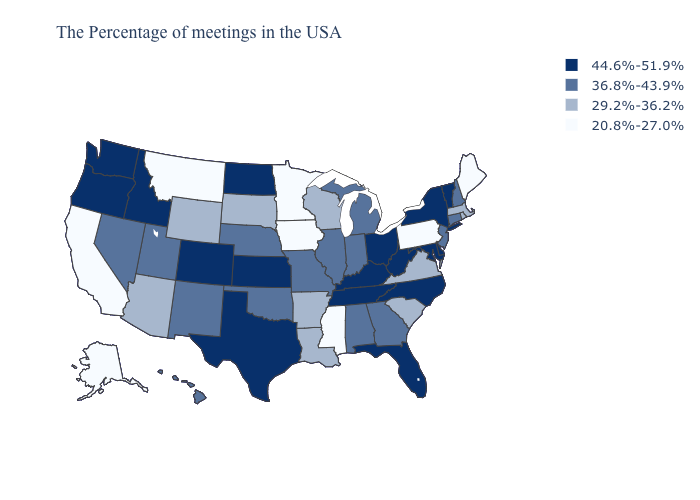Does Oklahoma have a higher value than Alaska?
Quick response, please. Yes. Name the states that have a value in the range 29.2%-36.2%?
Short answer required. Massachusetts, Rhode Island, Virginia, South Carolina, Wisconsin, Louisiana, Arkansas, South Dakota, Wyoming, Arizona. What is the highest value in the USA?
Keep it brief. 44.6%-51.9%. Name the states that have a value in the range 29.2%-36.2%?
Write a very short answer. Massachusetts, Rhode Island, Virginia, South Carolina, Wisconsin, Louisiana, Arkansas, South Dakota, Wyoming, Arizona. Name the states that have a value in the range 20.8%-27.0%?
Quick response, please. Maine, Pennsylvania, Mississippi, Minnesota, Iowa, Montana, California, Alaska. Is the legend a continuous bar?
Quick response, please. No. How many symbols are there in the legend?
Concise answer only. 4. What is the lowest value in states that border Delaware?
Give a very brief answer. 20.8%-27.0%. Name the states that have a value in the range 29.2%-36.2%?
Short answer required. Massachusetts, Rhode Island, Virginia, South Carolina, Wisconsin, Louisiana, Arkansas, South Dakota, Wyoming, Arizona. Among the states that border Kentucky , which have the lowest value?
Quick response, please. Virginia. What is the value of Missouri?
Give a very brief answer. 36.8%-43.9%. Among the states that border Texas , which have the lowest value?
Keep it brief. Louisiana, Arkansas. What is the lowest value in the USA?
Answer briefly. 20.8%-27.0%. What is the value of Ohio?
Be succinct. 44.6%-51.9%. 